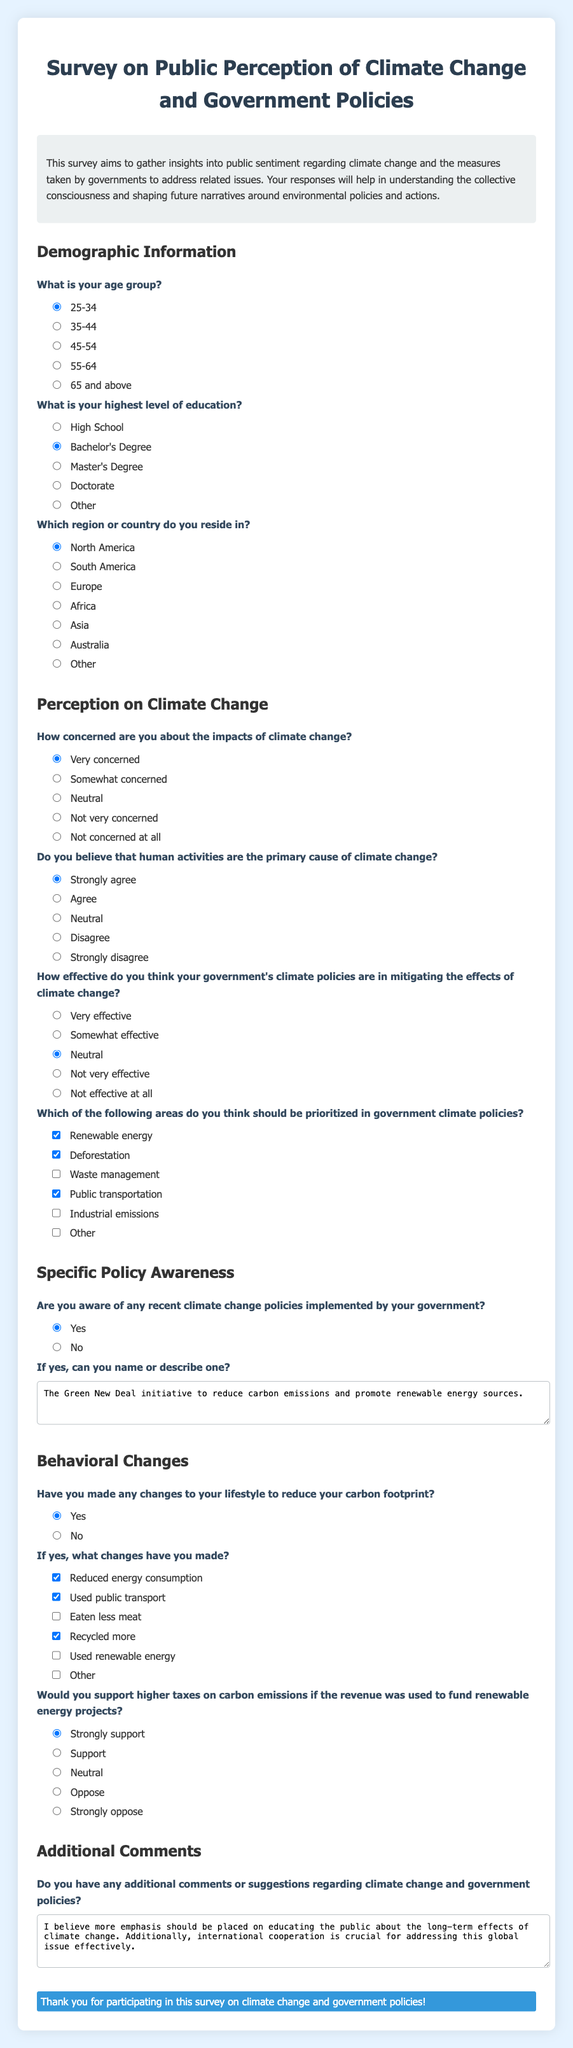What is the title of the survey? The title is located at the top of the document, stating the main focus of the survey.
Answer: Survey on Public Perception of Climate Change and Government Policies What age group is selected by default? The default selection for age is indicated by the checked radio button under the age question.
Answer: 25-34 How many options are provided for the highest level of education? The number of educational options is mentioned in the education section of the document.
Answer: 5 Which region is marked as the default selection? The default selection for the region is indicated by the checked radio button under the region question.
Answer: North America How do respondents feel about their government's climate policies? The respondents' feelings are summarized under the effectiveness question with various options including checked ones.
Answer: Neutral What is one climate change policy mentioned by a participant? The policy mentioned is recorded in the textarea following the awareness question about recent climate measures.
Answer: The Green New Deal initiative to reduce carbon emissions and promote renewable energy sources What lifestyle change is supported by most respondents? The lifestyle changes are listed, and the ones checked indicate popular responses to reducing carbon footprint.
Answer: Reduced energy consumption What is the respondents' stance on carbon taxes funding renewable energy projects? The question regarding taxation reflects attitudes toward carbon taxes, with a specific checked response.
Answer: Strongly support What is one suggestion mentioned in the additional comments? The textarea for additional comments contains participant suggestions regarding climate change awareness.
Answer: More emphasis should be placed on educating the public about the long-term effects of climate change 